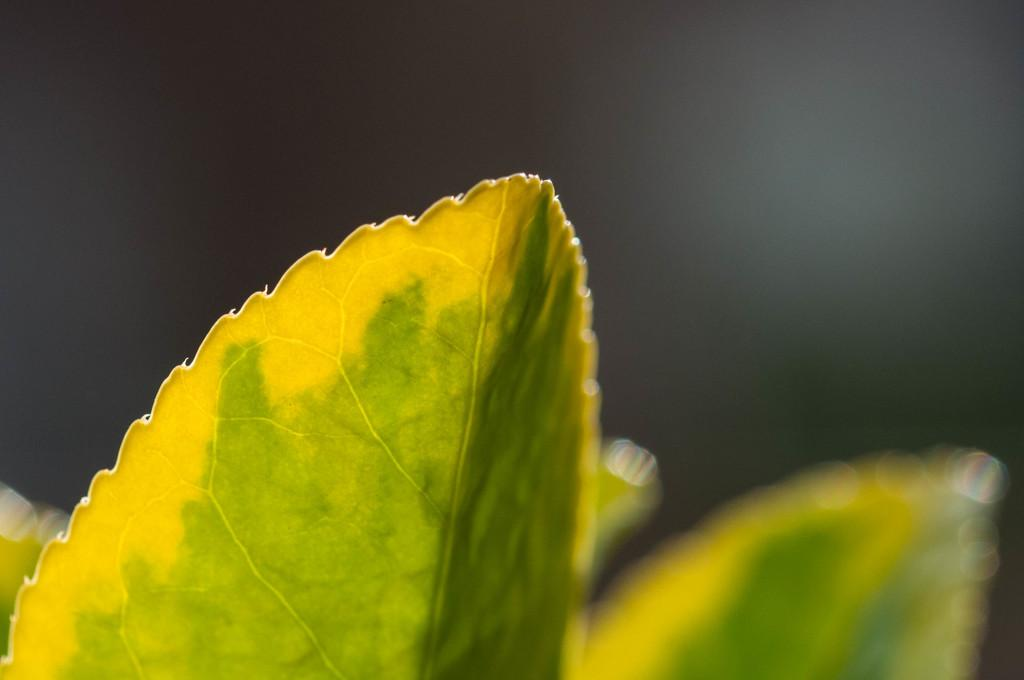What type of vegetation can be seen in the image? There are leaves in the image. Can you describe the background of the image? The background area of the image is blurred. What type of crime is being committed in the image? There is no indication of a crime being committed in the image; it features leaves and a blurred background. What type of oil can be seen in the image? There is no oil present in the image. 